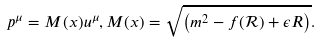<formula> <loc_0><loc_0><loc_500><loc_500>p ^ { \mu } = M ( x ) u ^ { \mu } , M ( x ) = \sqrt { \left ( m ^ { 2 } - f ( \mathcal { R } ) + \epsilon R \right ) } .</formula> 